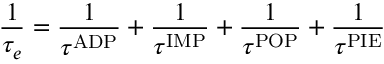Convert formula to latex. <formula><loc_0><loc_0><loc_500><loc_500>\frac { 1 } { \tau _ { e } } = \frac { 1 } { \tau ^ { A D P } } + \frac { 1 } { \tau ^ { I M P } } + \frac { 1 } { \tau ^ { P O P } } + \frac { 1 } { \tau ^ { P I E } }</formula> 